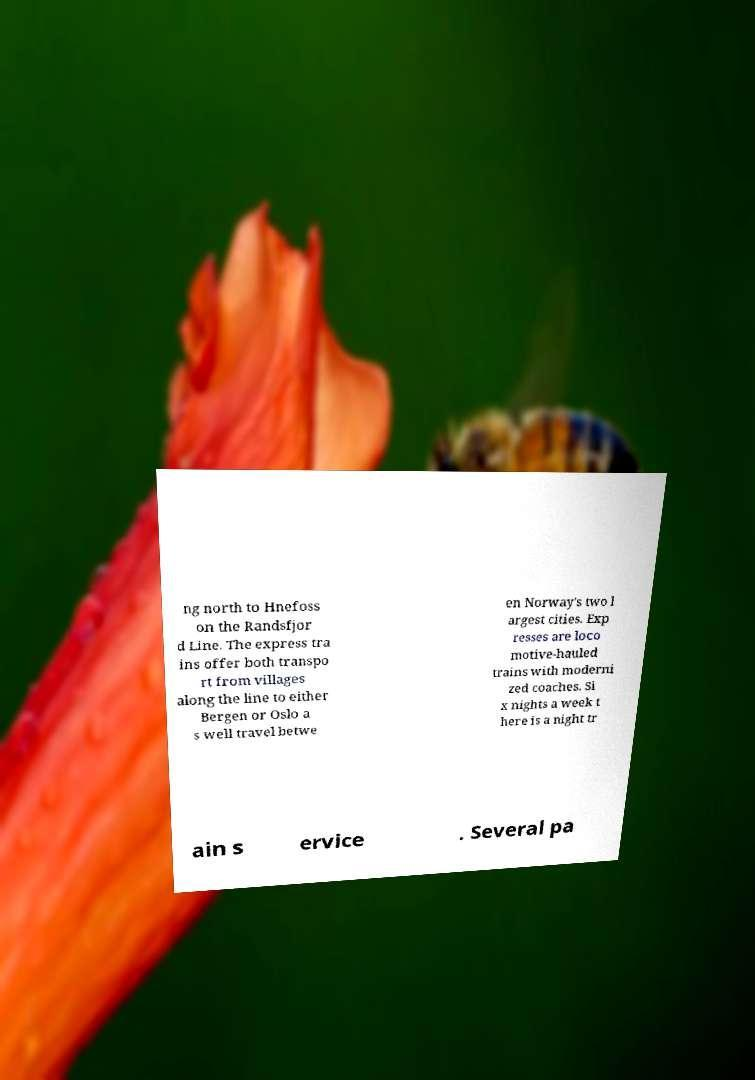Please identify and transcribe the text found in this image. ng north to Hnefoss on the Randsfjor d Line. The express tra ins offer both transpo rt from villages along the line to either Bergen or Oslo a s well travel betwe en Norway's two l argest cities. Exp resses are loco motive-hauled trains with moderni zed coaches. Si x nights a week t here is a night tr ain s ervice . Several pa 